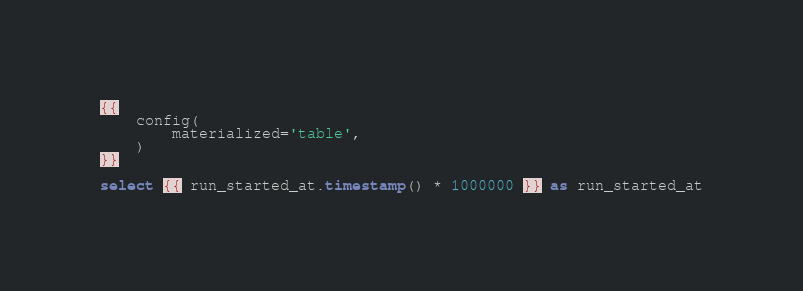Convert code to text. <code><loc_0><loc_0><loc_500><loc_500><_SQL_>{{
    config(
        materialized='table',
    )
}}

select {{ run_started_at.timestamp() * 1000000 }} as run_started_at</code> 